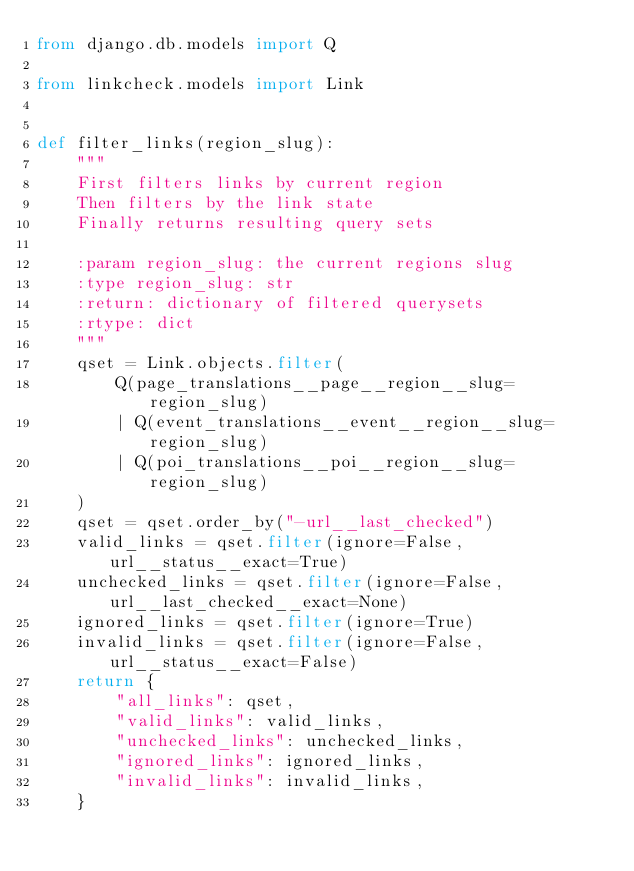<code> <loc_0><loc_0><loc_500><loc_500><_Python_>from django.db.models import Q

from linkcheck.models import Link


def filter_links(region_slug):
    """
    First filters links by current region
    Then filters by the link state
    Finally returns resulting query sets

    :param region_slug: the current regions slug
    :type region_slug: str
    :return: dictionary of filtered querysets
    :rtype: dict
    """
    qset = Link.objects.filter(
        Q(page_translations__page__region__slug=region_slug)
        | Q(event_translations__event__region__slug=region_slug)
        | Q(poi_translations__poi__region__slug=region_slug)
    )
    qset = qset.order_by("-url__last_checked")
    valid_links = qset.filter(ignore=False, url__status__exact=True)
    unchecked_links = qset.filter(ignore=False, url__last_checked__exact=None)
    ignored_links = qset.filter(ignore=True)
    invalid_links = qset.filter(ignore=False, url__status__exact=False)
    return {
        "all_links": qset,
        "valid_links": valid_links,
        "unchecked_links": unchecked_links,
        "ignored_links": ignored_links,
        "invalid_links": invalid_links,
    }
</code> 